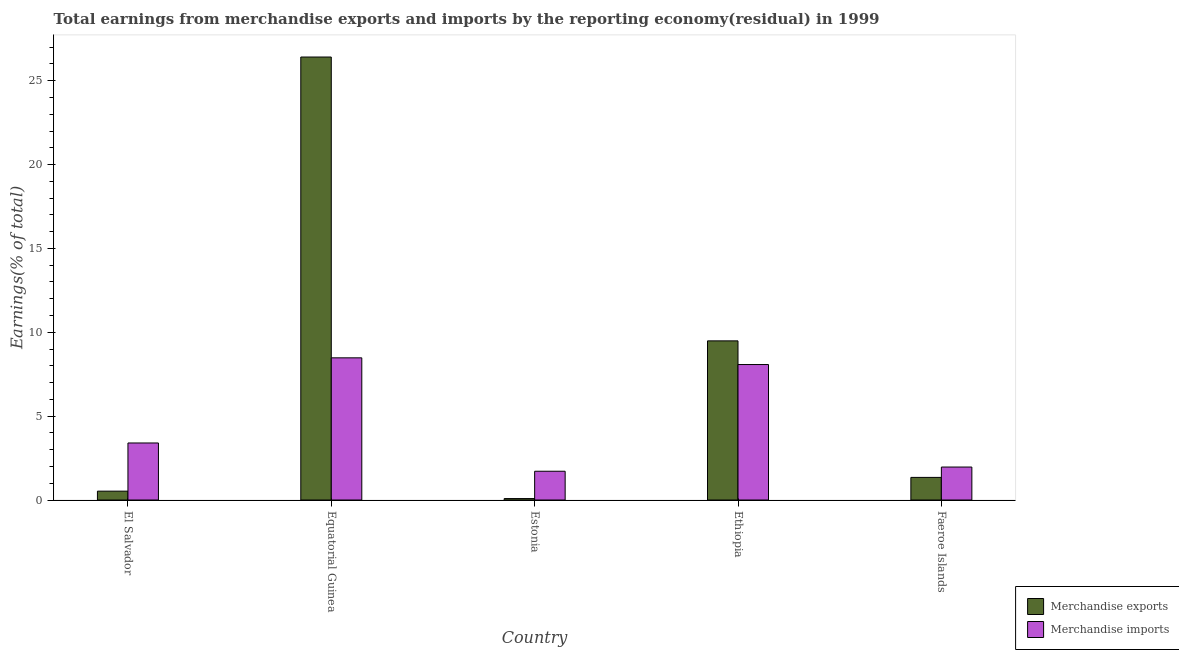How many different coloured bars are there?
Keep it short and to the point. 2. How many groups of bars are there?
Your answer should be very brief. 5. Are the number of bars on each tick of the X-axis equal?
Your answer should be compact. Yes. How many bars are there on the 1st tick from the left?
Ensure brevity in your answer.  2. How many bars are there on the 5th tick from the right?
Your answer should be very brief. 2. What is the label of the 4th group of bars from the left?
Offer a terse response. Ethiopia. In how many cases, is the number of bars for a given country not equal to the number of legend labels?
Your answer should be compact. 0. What is the earnings from merchandise exports in Estonia?
Your answer should be very brief. 0.09. Across all countries, what is the maximum earnings from merchandise imports?
Provide a short and direct response. 8.48. Across all countries, what is the minimum earnings from merchandise imports?
Your response must be concise. 1.72. In which country was the earnings from merchandise imports maximum?
Offer a terse response. Equatorial Guinea. In which country was the earnings from merchandise exports minimum?
Make the answer very short. Estonia. What is the total earnings from merchandise exports in the graph?
Ensure brevity in your answer.  37.86. What is the difference between the earnings from merchandise imports in Equatorial Guinea and that in Faeroe Islands?
Give a very brief answer. 6.51. What is the difference between the earnings from merchandise imports in Estonia and the earnings from merchandise exports in Faeroe Islands?
Ensure brevity in your answer.  0.37. What is the average earnings from merchandise exports per country?
Your answer should be very brief. 7.57. What is the difference between the earnings from merchandise imports and earnings from merchandise exports in Ethiopia?
Give a very brief answer. -1.41. What is the ratio of the earnings from merchandise imports in El Salvador to that in Faeroe Islands?
Keep it short and to the point. 1.73. Is the difference between the earnings from merchandise exports in Equatorial Guinea and Estonia greater than the difference between the earnings from merchandise imports in Equatorial Guinea and Estonia?
Give a very brief answer. Yes. What is the difference between the highest and the second highest earnings from merchandise imports?
Give a very brief answer. 0.4. What is the difference between the highest and the lowest earnings from merchandise exports?
Provide a succinct answer. 26.33. In how many countries, is the earnings from merchandise imports greater than the average earnings from merchandise imports taken over all countries?
Ensure brevity in your answer.  2. What does the 1st bar from the left in Faeroe Islands represents?
Your answer should be compact. Merchandise exports. How many countries are there in the graph?
Your answer should be very brief. 5. What is the difference between two consecutive major ticks on the Y-axis?
Your answer should be compact. 5. Does the graph contain grids?
Make the answer very short. No. Where does the legend appear in the graph?
Your answer should be very brief. Bottom right. What is the title of the graph?
Your response must be concise. Total earnings from merchandise exports and imports by the reporting economy(residual) in 1999. Does "Register a property" appear as one of the legend labels in the graph?
Offer a terse response. No. What is the label or title of the X-axis?
Your answer should be compact. Country. What is the label or title of the Y-axis?
Offer a terse response. Earnings(% of total). What is the Earnings(% of total) in Merchandise exports in El Salvador?
Offer a very short reply. 0.53. What is the Earnings(% of total) in Merchandise imports in El Salvador?
Keep it short and to the point. 3.4. What is the Earnings(% of total) of Merchandise exports in Equatorial Guinea?
Your response must be concise. 26.41. What is the Earnings(% of total) of Merchandise imports in Equatorial Guinea?
Ensure brevity in your answer.  8.48. What is the Earnings(% of total) of Merchandise exports in Estonia?
Offer a very short reply. 0.09. What is the Earnings(% of total) in Merchandise imports in Estonia?
Provide a succinct answer. 1.72. What is the Earnings(% of total) of Merchandise exports in Ethiopia?
Make the answer very short. 9.49. What is the Earnings(% of total) of Merchandise imports in Ethiopia?
Provide a short and direct response. 8.08. What is the Earnings(% of total) of Merchandise exports in Faeroe Islands?
Make the answer very short. 1.35. What is the Earnings(% of total) of Merchandise imports in Faeroe Islands?
Ensure brevity in your answer.  1.97. Across all countries, what is the maximum Earnings(% of total) of Merchandise exports?
Make the answer very short. 26.41. Across all countries, what is the maximum Earnings(% of total) in Merchandise imports?
Your answer should be very brief. 8.48. Across all countries, what is the minimum Earnings(% of total) in Merchandise exports?
Offer a very short reply. 0.09. Across all countries, what is the minimum Earnings(% of total) of Merchandise imports?
Your response must be concise. 1.72. What is the total Earnings(% of total) in Merchandise exports in the graph?
Offer a terse response. 37.86. What is the total Earnings(% of total) of Merchandise imports in the graph?
Give a very brief answer. 23.64. What is the difference between the Earnings(% of total) of Merchandise exports in El Salvador and that in Equatorial Guinea?
Provide a short and direct response. -25.88. What is the difference between the Earnings(% of total) in Merchandise imports in El Salvador and that in Equatorial Guinea?
Your answer should be compact. -5.08. What is the difference between the Earnings(% of total) in Merchandise exports in El Salvador and that in Estonia?
Provide a short and direct response. 0.44. What is the difference between the Earnings(% of total) of Merchandise imports in El Salvador and that in Estonia?
Ensure brevity in your answer.  1.69. What is the difference between the Earnings(% of total) in Merchandise exports in El Salvador and that in Ethiopia?
Your answer should be very brief. -8.96. What is the difference between the Earnings(% of total) of Merchandise imports in El Salvador and that in Ethiopia?
Your answer should be very brief. -4.68. What is the difference between the Earnings(% of total) of Merchandise exports in El Salvador and that in Faeroe Islands?
Offer a terse response. -0.82. What is the difference between the Earnings(% of total) of Merchandise imports in El Salvador and that in Faeroe Islands?
Keep it short and to the point. 1.43. What is the difference between the Earnings(% of total) in Merchandise exports in Equatorial Guinea and that in Estonia?
Your answer should be very brief. 26.33. What is the difference between the Earnings(% of total) in Merchandise imports in Equatorial Guinea and that in Estonia?
Provide a succinct answer. 6.76. What is the difference between the Earnings(% of total) of Merchandise exports in Equatorial Guinea and that in Ethiopia?
Provide a short and direct response. 16.92. What is the difference between the Earnings(% of total) in Merchandise imports in Equatorial Guinea and that in Ethiopia?
Provide a short and direct response. 0.4. What is the difference between the Earnings(% of total) in Merchandise exports in Equatorial Guinea and that in Faeroe Islands?
Offer a terse response. 25.07. What is the difference between the Earnings(% of total) of Merchandise imports in Equatorial Guinea and that in Faeroe Islands?
Your response must be concise. 6.51. What is the difference between the Earnings(% of total) in Merchandise exports in Estonia and that in Ethiopia?
Offer a terse response. -9.4. What is the difference between the Earnings(% of total) in Merchandise imports in Estonia and that in Ethiopia?
Give a very brief answer. -6.36. What is the difference between the Earnings(% of total) of Merchandise exports in Estonia and that in Faeroe Islands?
Your answer should be compact. -1.26. What is the difference between the Earnings(% of total) in Merchandise imports in Estonia and that in Faeroe Islands?
Offer a terse response. -0.25. What is the difference between the Earnings(% of total) of Merchandise exports in Ethiopia and that in Faeroe Islands?
Your answer should be compact. 8.14. What is the difference between the Earnings(% of total) in Merchandise imports in Ethiopia and that in Faeroe Islands?
Give a very brief answer. 6.11. What is the difference between the Earnings(% of total) of Merchandise exports in El Salvador and the Earnings(% of total) of Merchandise imports in Equatorial Guinea?
Make the answer very short. -7.95. What is the difference between the Earnings(% of total) of Merchandise exports in El Salvador and the Earnings(% of total) of Merchandise imports in Estonia?
Ensure brevity in your answer.  -1.19. What is the difference between the Earnings(% of total) of Merchandise exports in El Salvador and the Earnings(% of total) of Merchandise imports in Ethiopia?
Make the answer very short. -7.55. What is the difference between the Earnings(% of total) in Merchandise exports in El Salvador and the Earnings(% of total) in Merchandise imports in Faeroe Islands?
Your answer should be very brief. -1.44. What is the difference between the Earnings(% of total) of Merchandise exports in Equatorial Guinea and the Earnings(% of total) of Merchandise imports in Estonia?
Your answer should be compact. 24.7. What is the difference between the Earnings(% of total) in Merchandise exports in Equatorial Guinea and the Earnings(% of total) in Merchandise imports in Ethiopia?
Your answer should be compact. 18.34. What is the difference between the Earnings(% of total) in Merchandise exports in Equatorial Guinea and the Earnings(% of total) in Merchandise imports in Faeroe Islands?
Ensure brevity in your answer.  24.45. What is the difference between the Earnings(% of total) in Merchandise exports in Estonia and the Earnings(% of total) in Merchandise imports in Ethiopia?
Make the answer very short. -7.99. What is the difference between the Earnings(% of total) of Merchandise exports in Estonia and the Earnings(% of total) of Merchandise imports in Faeroe Islands?
Provide a short and direct response. -1.88. What is the difference between the Earnings(% of total) in Merchandise exports in Ethiopia and the Earnings(% of total) in Merchandise imports in Faeroe Islands?
Make the answer very short. 7.52. What is the average Earnings(% of total) of Merchandise exports per country?
Offer a very short reply. 7.57. What is the average Earnings(% of total) of Merchandise imports per country?
Ensure brevity in your answer.  4.73. What is the difference between the Earnings(% of total) in Merchandise exports and Earnings(% of total) in Merchandise imports in El Salvador?
Your response must be concise. -2.87. What is the difference between the Earnings(% of total) of Merchandise exports and Earnings(% of total) of Merchandise imports in Equatorial Guinea?
Provide a succinct answer. 17.94. What is the difference between the Earnings(% of total) in Merchandise exports and Earnings(% of total) in Merchandise imports in Estonia?
Provide a short and direct response. -1.63. What is the difference between the Earnings(% of total) in Merchandise exports and Earnings(% of total) in Merchandise imports in Ethiopia?
Your answer should be very brief. 1.41. What is the difference between the Earnings(% of total) of Merchandise exports and Earnings(% of total) of Merchandise imports in Faeroe Islands?
Offer a terse response. -0.62. What is the ratio of the Earnings(% of total) in Merchandise exports in El Salvador to that in Equatorial Guinea?
Provide a short and direct response. 0.02. What is the ratio of the Earnings(% of total) in Merchandise imports in El Salvador to that in Equatorial Guinea?
Your answer should be compact. 0.4. What is the ratio of the Earnings(% of total) of Merchandise exports in El Salvador to that in Estonia?
Make the answer very short. 6.19. What is the ratio of the Earnings(% of total) in Merchandise imports in El Salvador to that in Estonia?
Offer a very short reply. 1.98. What is the ratio of the Earnings(% of total) of Merchandise exports in El Salvador to that in Ethiopia?
Give a very brief answer. 0.06. What is the ratio of the Earnings(% of total) in Merchandise imports in El Salvador to that in Ethiopia?
Provide a succinct answer. 0.42. What is the ratio of the Earnings(% of total) in Merchandise exports in El Salvador to that in Faeroe Islands?
Provide a short and direct response. 0.39. What is the ratio of the Earnings(% of total) of Merchandise imports in El Salvador to that in Faeroe Islands?
Offer a very short reply. 1.73. What is the ratio of the Earnings(% of total) of Merchandise exports in Equatorial Guinea to that in Estonia?
Provide a short and direct response. 309.65. What is the ratio of the Earnings(% of total) of Merchandise imports in Equatorial Guinea to that in Estonia?
Offer a terse response. 4.94. What is the ratio of the Earnings(% of total) of Merchandise exports in Equatorial Guinea to that in Ethiopia?
Make the answer very short. 2.78. What is the ratio of the Earnings(% of total) of Merchandise imports in Equatorial Guinea to that in Ethiopia?
Offer a terse response. 1.05. What is the ratio of the Earnings(% of total) of Merchandise exports in Equatorial Guinea to that in Faeroe Islands?
Ensure brevity in your answer.  19.6. What is the ratio of the Earnings(% of total) of Merchandise imports in Equatorial Guinea to that in Faeroe Islands?
Offer a very short reply. 4.31. What is the ratio of the Earnings(% of total) of Merchandise exports in Estonia to that in Ethiopia?
Keep it short and to the point. 0.01. What is the ratio of the Earnings(% of total) in Merchandise imports in Estonia to that in Ethiopia?
Provide a short and direct response. 0.21. What is the ratio of the Earnings(% of total) in Merchandise exports in Estonia to that in Faeroe Islands?
Ensure brevity in your answer.  0.06. What is the ratio of the Earnings(% of total) of Merchandise imports in Estonia to that in Faeroe Islands?
Provide a short and direct response. 0.87. What is the ratio of the Earnings(% of total) of Merchandise exports in Ethiopia to that in Faeroe Islands?
Make the answer very short. 7.04. What is the ratio of the Earnings(% of total) in Merchandise imports in Ethiopia to that in Faeroe Islands?
Make the answer very short. 4.11. What is the difference between the highest and the second highest Earnings(% of total) of Merchandise exports?
Provide a succinct answer. 16.92. What is the difference between the highest and the second highest Earnings(% of total) in Merchandise imports?
Offer a very short reply. 0.4. What is the difference between the highest and the lowest Earnings(% of total) of Merchandise exports?
Your answer should be very brief. 26.33. What is the difference between the highest and the lowest Earnings(% of total) in Merchandise imports?
Offer a very short reply. 6.76. 